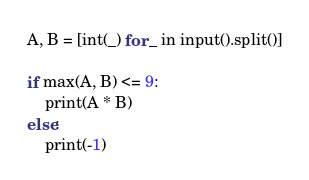Convert code to text. <code><loc_0><loc_0><loc_500><loc_500><_Python_>A, B = [int(_) for _ in input().split()]

if max(A, B) <= 9:
    print(A * B)
else:
    print(-1)
</code> 